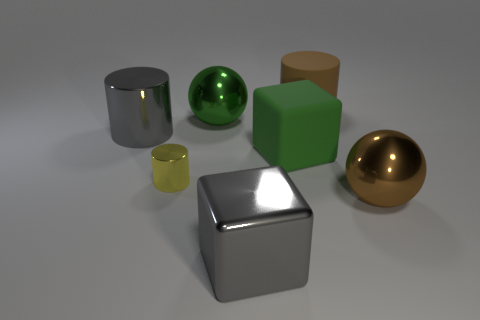Subtract 1 cylinders. How many cylinders are left? 2 Add 3 yellow cylinders. How many objects exist? 10 Subtract all cylinders. How many objects are left? 4 Subtract 0 gray balls. How many objects are left? 7 Subtract all large green cubes. Subtract all large rubber cylinders. How many objects are left? 5 Add 4 large brown cylinders. How many large brown cylinders are left? 5 Add 7 small green objects. How many small green objects exist? 7 